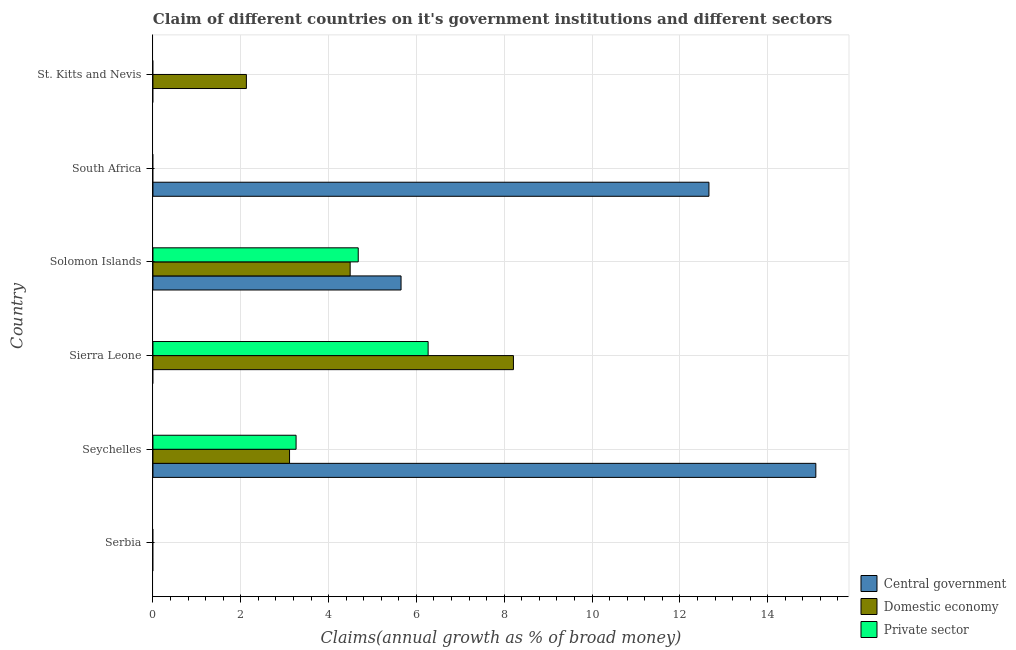How many bars are there on the 2nd tick from the bottom?
Make the answer very short. 3. What is the label of the 1st group of bars from the top?
Provide a succinct answer. St. Kitts and Nevis. What is the percentage of claim on the central government in Solomon Islands?
Your answer should be very brief. 5.65. Across all countries, what is the maximum percentage of claim on the private sector?
Keep it short and to the point. 6.27. Across all countries, what is the minimum percentage of claim on the domestic economy?
Your answer should be very brief. 0. In which country was the percentage of claim on the private sector maximum?
Give a very brief answer. Sierra Leone. What is the total percentage of claim on the central government in the graph?
Offer a terse response. 33.41. What is the difference between the percentage of claim on the domestic economy in Seychelles and that in Solomon Islands?
Your response must be concise. -1.38. What is the difference between the percentage of claim on the private sector in St. Kitts and Nevis and the percentage of claim on the central government in Sierra Leone?
Your answer should be compact. 0. What is the average percentage of claim on the central government per country?
Your answer should be compact. 5.57. What is the difference between the percentage of claim on the private sector and percentage of claim on the central government in Solomon Islands?
Offer a very short reply. -0.97. What is the difference between the highest and the second highest percentage of claim on the domestic economy?
Offer a very short reply. 3.72. What is the difference between the highest and the lowest percentage of claim on the domestic economy?
Your answer should be compact. 8.21. In how many countries, is the percentage of claim on the private sector greater than the average percentage of claim on the private sector taken over all countries?
Provide a succinct answer. 3. How many bars are there?
Your answer should be compact. 10. What is the difference between two consecutive major ticks on the X-axis?
Your response must be concise. 2. Does the graph contain any zero values?
Your response must be concise. Yes. What is the title of the graph?
Provide a short and direct response. Claim of different countries on it's government institutions and different sectors. Does "Agricultural Nitrous Oxide" appear as one of the legend labels in the graph?
Give a very brief answer. No. What is the label or title of the X-axis?
Your answer should be very brief. Claims(annual growth as % of broad money). What is the Claims(annual growth as % of broad money) in Central government in Serbia?
Keep it short and to the point. 0. What is the Claims(annual growth as % of broad money) in Domestic economy in Serbia?
Ensure brevity in your answer.  0. What is the Claims(annual growth as % of broad money) of Private sector in Serbia?
Give a very brief answer. 0. What is the Claims(annual growth as % of broad money) of Central government in Seychelles?
Provide a short and direct response. 15.1. What is the Claims(annual growth as % of broad money) of Domestic economy in Seychelles?
Offer a very short reply. 3.11. What is the Claims(annual growth as % of broad money) in Private sector in Seychelles?
Your answer should be compact. 3.26. What is the Claims(annual growth as % of broad money) in Central government in Sierra Leone?
Your answer should be compact. 0. What is the Claims(annual growth as % of broad money) of Domestic economy in Sierra Leone?
Make the answer very short. 8.21. What is the Claims(annual growth as % of broad money) in Private sector in Sierra Leone?
Offer a terse response. 6.27. What is the Claims(annual growth as % of broad money) of Central government in Solomon Islands?
Offer a terse response. 5.65. What is the Claims(annual growth as % of broad money) in Domestic economy in Solomon Islands?
Provide a short and direct response. 4.49. What is the Claims(annual growth as % of broad money) of Private sector in Solomon Islands?
Your answer should be compact. 4.68. What is the Claims(annual growth as % of broad money) of Central government in South Africa?
Give a very brief answer. 12.66. What is the Claims(annual growth as % of broad money) in Domestic economy in South Africa?
Provide a succinct answer. 0. What is the Claims(annual growth as % of broad money) in Private sector in South Africa?
Provide a short and direct response. 0. What is the Claims(annual growth as % of broad money) in Central government in St. Kitts and Nevis?
Your answer should be compact. 0. What is the Claims(annual growth as % of broad money) in Domestic economy in St. Kitts and Nevis?
Provide a short and direct response. 2.13. Across all countries, what is the maximum Claims(annual growth as % of broad money) in Central government?
Offer a terse response. 15.1. Across all countries, what is the maximum Claims(annual growth as % of broad money) of Domestic economy?
Your response must be concise. 8.21. Across all countries, what is the maximum Claims(annual growth as % of broad money) of Private sector?
Give a very brief answer. 6.27. Across all countries, what is the minimum Claims(annual growth as % of broad money) of Central government?
Provide a short and direct response. 0. Across all countries, what is the minimum Claims(annual growth as % of broad money) in Domestic economy?
Provide a succinct answer. 0. Across all countries, what is the minimum Claims(annual growth as % of broad money) in Private sector?
Make the answer very short. 0. What is the total Claims(annual growth as % of broad money) of Central government in the graph?
Your answer should be compact. 33.41. What is the total Claims(annual growth as % of broad money) of Domestic economy in the graph?
Offer a very short reply. 17.94. What is the total Claims(annual growth as % of broad money) in Private sector in the graph?
Provide a succinct answer. 14.2. What is the difference between the Claims(annual growth as % of broad money) of Domestic economy in Seychelles and that in Sierra Leone?
Provide a short and direct response. -5.1. What is the difference between the Claims(annual growth as % of broad money) in Private sector in Seychelles and that in Sierra Leone?
Provide a short and direct response. -3.01. What is the difference between the Claims(annual growth as % of broad money) in Central government in Seychelles and that in Solomon Islands?
Offer a very short reply. 9.45. What is the difference between the Claims(annual growth as % of broad money) in Domestic economy in Seychelles and that in Solomon Islands?
Offer a very short reply. -1.38. What is the difference between the Claims(annual growth as % of broad money) of Private sector in Seychelles and that in Solomon Islands?
Your answer should be compact. -1.42. What is the difference between the Claims(annual growth as % of broad money) of Central government in Seychelles and that in South Africa?
Your answer should be very brief. 2.43. What is the difference between the Claims(annual growth as % of broad money) of Domestic economy in Seychelles and that in St. Kitts and Nevis?
Provide a succinct answer. 0.98. What is the difference between the Claims(annual growth as % of broad money) of Domestic economy in Sierra Leone and that in Solomon Islands?
Provide a succinct answer. 3.72. What is the difference between the Claims(annual growth as % of broad money) in Private sector in Sierra Leone and that in Solomon Islands?
Make the answer very short. 1.59. What is the difference between the Claims(annual growth as % of broad money) in Domestic economy in Sierra Leone and that in St. Kitts and Nevis?
Provide a short and direct response. 6.08. What is the difference between the Claims(annual growth as % of broad money) of Central government in Solomon Islands and that in South Africa?
Your answer should be very brief. -7.01. What is the difference between the Claims(annual growth as % of broad money) in Domestic economy in Solomon Islands and that in St. Kitts and Nevis?
Ensure brevity in your answer.  2.36. What is the difference between the Claims(annual growth as % of broad money) in Central government in Seychelles and the Claims(annual growth as % of broad money) in Domestic economy in Sierra Leone?
Offer a very short reply. 6.89. What is the difference between the Claims(annual growth as % of broad money) in Central government in Seychelles and the Claims(annual growth as % of broad money) in Private sector in Sierra Leone?
Your answer should be compact. 8.83. What is the difference between the Claims(annual growth as % of broad money) of Domestic economy in Seychelles and the Claims(annual growth as % of broad money) of Private sector in Sierra Leone?
Provide a short and direct response. -3.16. What is the difference between the Claims(annual growth as % of broad money) in Central government in Seychelles and the Claims(annual growth as % of broad money) in Domestic economy in Solomon Islands?
Make the answer very short. 10.6. What is the difference between the Claims(annual growth as % of broad money) of Central government in Seychelles and the Claims(annual growth as % of broad money) of Private sector in Solomon Islands?
Ensure brevity in your answer.  10.42. What is the difference between the Claims(annual growth as % of broad money) of Domestic economy in Seychelles and the Claims(annual growth as % of broad money) of Private sector in Solomon Islands?
Offer a terse response. -1.56. What is the difference between the Claims(annual growth as % of broad money) in Central government in Seychelles and the Claims(annual growth as % of broad money) in Domestic economy in St. Kitts and Nevis?
Offer a very short reply. 12.97. What is the difference between the Claims(annual growth as % of broad money) in Domestic economy in Sierra Leone and the Claims(annual growth as % of broad money) in Private sector in Solomon Islands?
Make the answer very short. 3.53. What is the difference between the Claims(annual growth as % of broad money) in Central government in Solomon Islands and the Claims(annual growth as % of broad money) in Domestic economy in St. Kitts and Nevis?
Make the answer very short. 3.52. What is the difference between the Claims(annual growth as % of broad money) in Central government in South Africa and the Claims(annual growth as % of broad money) in Domestic economy in St. Kitts and Nevis?
Keep it short and to the point. 10.53. What is the average Claims(annual growth as % of broad money) of Central government per country?
Your response must be concise. 5.57. What is the average Claims(annual growth as % of broad money) of Domestic economy per country?
Offer a terse response. 2.99. What is the average Claims(annual growth as % of broad money) of Private sector per country?
Give a very brief answer. 2.37. What is the difference between the Claims(annual growth as % of broad money) in Central government and Claims(annual growth as % of broad money) in Domestic economy in Seychelles?
Offer a very short reply. 11.99. What is the difference between the Claims(annual growth as % of broad money) in Central government and Claims(annual growth as % of broad money) in Private sector in Seychelles?
Your answer should be compact. 11.84. What is the difference between the Claims(annual growth as % of broad money) of Domestic economy and Claims(annual growth as % of broad money) of Private sector in Seychelles?
Offer a terse response. -0.15. What is the difference between the Claims(annual growth as % of broad money) in Domestic economy and Claims(annual growth as % of broad money) in Private sector in Sierra Leone?
Keep it short and to the point. 1.94. What is the difference between the Claims(annual growth as % of broad money) of Central government and Claims(annual growth as % of broad money) of Domestic economy in Solomon Islands?
Your answer should be very brief. 1.16. What is the difference between the Claims(annual growth as % of broad money) in Central government and Claims(annual growth as % of broad money) in Private sector in Solomon Islands?
Make the answer very short. 0.97. What is the difference between the Claims(annual growth as % of broad money) in Domestic economy and Claims(annual growth as % of broad money) in Private sector in Solomon Islands?
Offer a terse response. -0.18. What is the ratio of the Claims(annual growth as % of broad money) in Domestic economy in Seychelles to that in Sierra Leone?
Ensure brevity in your answer.  0.38. What is the ratio of the Claims(annual growth as % of broad money) of Private sector in Seychelles to that in Sierra Leone?
Your response must be concise. 0.52. What is the ratio of the Claims(annual growth as % of broad money) of Central government in Seychelles to that in Solomon Islands?
Make the answer very short. 2.67. What is the ratio of the Claims(annual growth as % of broad money) in Domestic economy in Seychelles to that in Solomon Islands?
Make the answer very short. 0.69. What is the ratio of the Claims(annual growth as % of broad money) of Private sector in Seychelles to that in Solomon Islands?
Provide a short and direct response. 0.7. What is the ratio of the Claims(annual growth as % of broad money) in Central government in Seychelles to that in South Africa?
Ensure brevity in your answer.  1.19. What is the ratio of the Claims(annual growth as % of broad money) of Domestic economy in Seychelles to that in St. Kitts and Nevis?
Offer a terse response. 1.46. What is the ratio of the Claims(annual growth as % of broad money) of Domestic economy in Sierra Leone to that in Solomon Islands?
Ensure brevity in your answer.  1.83. What is the ratio of the Claims(annual growth as % of broad money) in Private sector in Sierra Leone to that in Solomon Islands?
Provide a short and direct response. 1.34. What is the ratio of the Claims(annual growth as % of broad money) in Domestic economy in Sierra Leone to that in St. Kitts and Nevis?
Give a very brief answer. 3.86. What is the ratio of the Claims(annual growth as % of broad money) in Central government in Solomon Islands to that in South Africa?
Make the answer very short. 0.45. What is the ratio of the Claims(annual growth as % of broad money) of Domestic economy in Solomon Islands to that in St. Kitts and Nevis?
Offer a very short reply. 2.11. What is the difference between the highest and the second highest Claims(annual growth as % of broad money) of Central government?
Provide a short and direct response. 2.43. What is the difference between the highest and the second highest Claims(annual growth as % of broad money) of Domestic economy?
Your answer should be very brief. 3.72. What is the difference between the highest and the second highest Claims(annual growth as % of broad money) in Private sector?
Offer a very short reply. 1.59. What is the difference between the highest and the lowest Claims(annual growth as % of broad money) in Central government?
Ensure brevity in your answer.  15.1. What is the difference between the highest and the lowest Claims(annual growth as % of broad money) in Domestic economy?
Provide a short and direct response. 8.21. What is the difference between the highest and the lowest Claims(annual growth as % of broad money) in Private sector?
Your answer should be very brief. 6.27. 